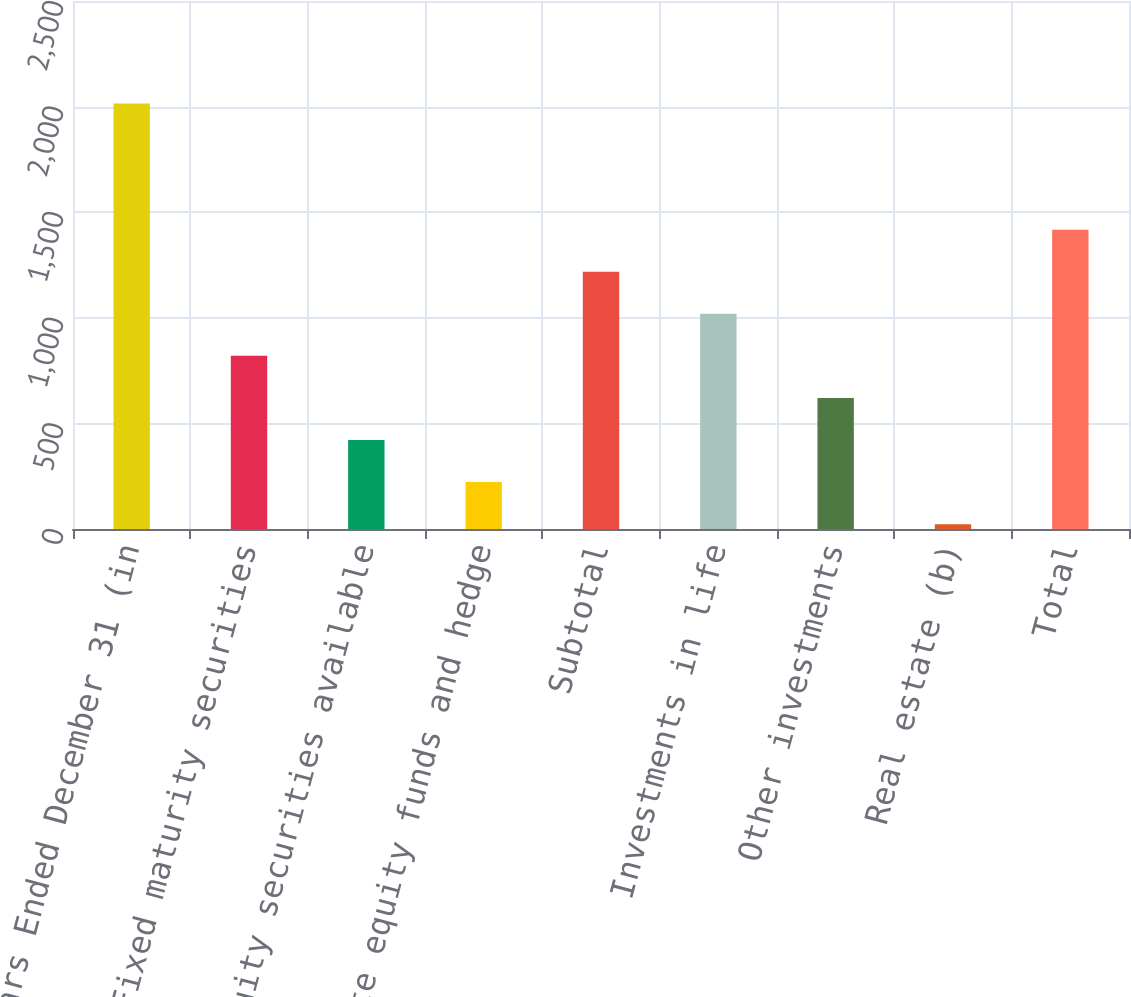Convert chart to OTSL. <chart><loc_0><loc_0><loc_500><loc_500><bar_chart><fcel>Years Ended December 31 (in<fcel>Fixed maturity securities<fcel>Equity securities available<fcel>Private equity funds and hedge<fcel>Subtotal<fcel>Investments in life<fcel>Other investments<fcel>Real estate (b)<fcel>Total<nl><fcel>2015<fcel>819.8<fcel>421.4<fcel>222.2<fcel>1218.2<fcel>1019<fcel>620.6<fcel>23<fcel>1417.4<nl></chart> 